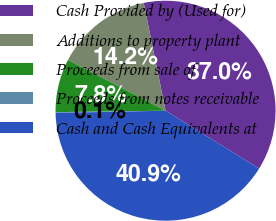<chart> <loc_0><loc_0><loc_500><loc_500><pie_chart><fcel>Cash Provided by (Used for)<fcel>Additions to property plant<fcel>Proceeds from sale of<fcel>Proceeds from notes receivable<fcel>Cash and Cash Equivalents at<nl><fcel>37.0%<fcel>14.18%<fcel>7.84%<fcel>0.12%<fcel>40.86%<nl></chart> 